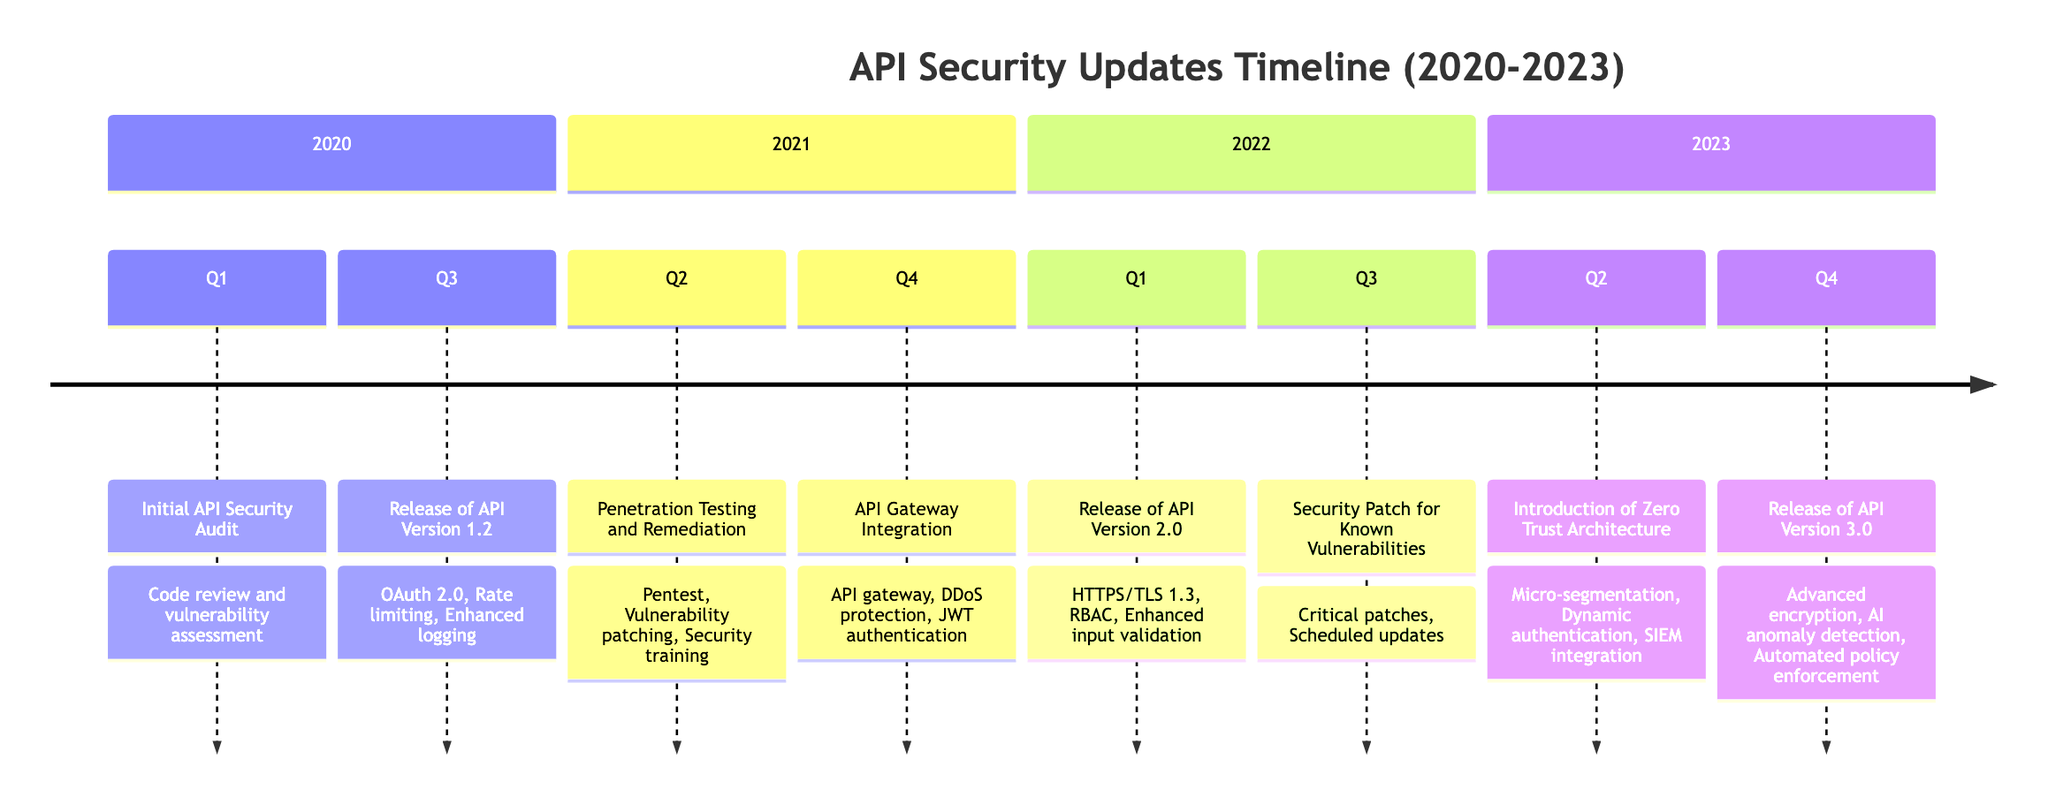What was the first major security milestone in 2020? The diagram indicates that the first major security milestone in 2020 was the "Initial API Security Audit," which is listed under Q1.
Answer: Initial API Security Audit How many critical security patches were applied in 2022? In 2022, the diagram notes a "Security Patch for Known Vulnerabilities" in Q3, which involved the application of critical security patches.
Answer: Critical security patches What new feature was introduced during the API Gateway Integration in 2021? During Q4 of 2021, the diagram specifies the introduction of an "API gateway for central management" as one of the new features.
Answer: API gateway for central management Which API version had enhanced logging features? The diagram states that "Enhanced logging for security events" was included in the release of API Version 1.2 in Q3 of 2020.
Answer: API Version 1.2 What is one key feature of API Version 3.0 set to release in 2023? According to the diagram, one of the features for API Version 3.0 releasing in Q4 of 2023 is "Advanced encryption mechanisms."
Answer: Advanced encryption mechanisms What significant architectural approach was introduced in the second quarter of 2023? The timeline notes the introduction of "Zero Trust Architecture" in Q2 of 2023 as a significant change.
Answer: Zero Trust Architecture How many quarters in total contained milestones from 2020 to 2023? The timeline has a milestone in each of the eight quarters spanning from Q1 2020 to Q4 2023, resulting in a total of eight quarters with milestones.
Answer: Eight quarters What type of security training was implemented in 2021? In Q2 of 2021, the diagram mentions that "Security training for developers" was one of the new features implemented.
Answer: Security training for developers What is the main focus of the new features in the 2022 update? The main focus in 2022, particularly in Q1, was on security enhancements like "Full adoption of HTTPS/TLS 1.3," signaling a push towards improved security protocols.
Answer: Full adoption of HTTPS/TLS 1.3 